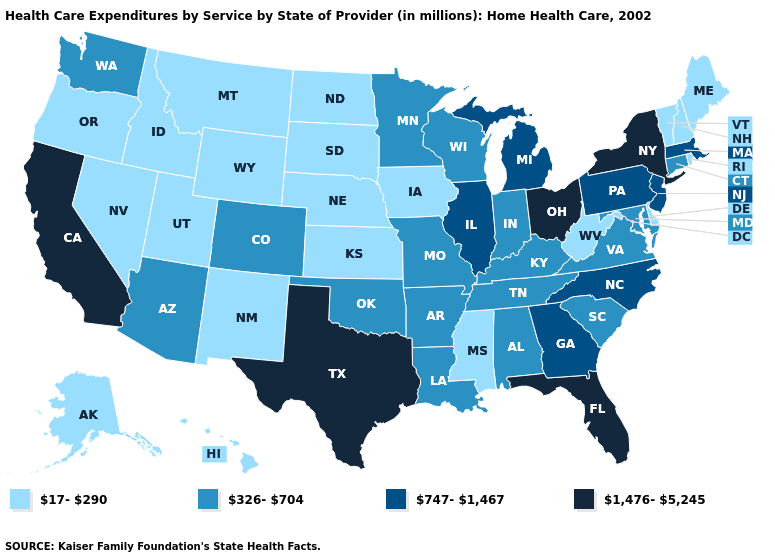Name the states that have a value in the range 17-290?
Answer briefly. Alaska, Delaware, Hawaii, Idaho, Iowa, Kansas, Maine, Mississippi, Montana, Nebraska, Nevada, New Hampshire, New Mexico, North Dakota, Oregon, Rhode Island, South Dakota, Utah, Vermont, West Virginia, Wyoming. Does California have the highest value in the USA?
Concise answer only. Yes. What is the highest value in states that border Maine?
Concise answer only. 17-290. Does Florida have the highest value in the South?
Keep it brief. Yes. What is the value of Connecticut?
Short answer required. 326-704. Does the map have missing data?
Be succinct. No. What is the value of California?
Answer briefly. 1,476-5,245. What is the value of Delaware?
Concise answer only. 17-290. What is the value of Illinois?
Write a very short answer. 747-1,467. What is the value of Massachusetts?
Give a very brief answer. 747-1,467. Name the states that have a value in the range 17-290?
Give a very brief answer. Alaska, Delaware, Hawaii, Idaho, Iowa, Kansas, Maine, Mississippi, Montana, Nebraska, Nevada, New Hampshire, New Mexico, North Dakota, Oregon, Rhode Island, South Dakota, Utah, Vermont, West Virginia, Wyoming. Among the states that border Massachusetts , does New York have the lowest value?
Quick response, please. No. What is the value of South Carolina?
Short answer required. 326-704. What is the highest value in states that border New Mexico?
Write a very short answer. 1,476-5,245. Which states have the lowest value in the USA?
Keep it brief. Alaska, Delaware, Hawaii, Idaho, Iowa, Kansas, Maine, Mississippi, Montana, Nebraska, Nevada, New Hampshire, New Mexico, North Dakota, Oregon, Rhode Island, South Dakota, Utah, Vermont, West Virginia, Wyoming. 